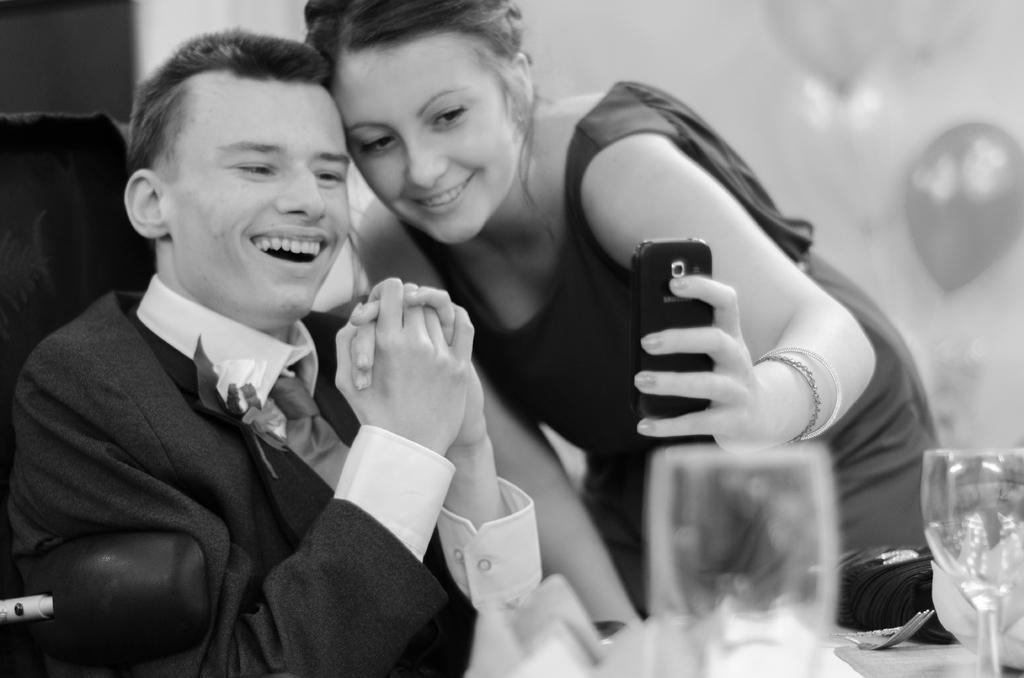Can you describe this image briefly? In this picture there is a black and white photography of the boy wearing a black color coat, smiling and giving a pose. Beside there is a woman wearing a black top, standing and taking photos in the mobile. In the front there is a table on which wine glasses are placed. Behind there is a blur background. 